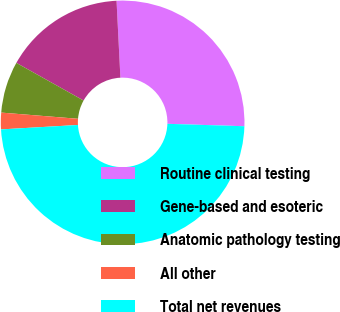Convert chart to OTSL. <chart><loc_0><loc_0><loc_500><loc_500><pie_chart><fcel>Routine clinical testing<fcel>Gene-based and esoteric<fcel>Anatomic pathology testing<fcel>All other<fcel>Total net revenues<nl><fcel>26.3%<fcel>16.08%<fcel>6.84%<fcel>2.2%<fcel>48.59%<nl></chart> 